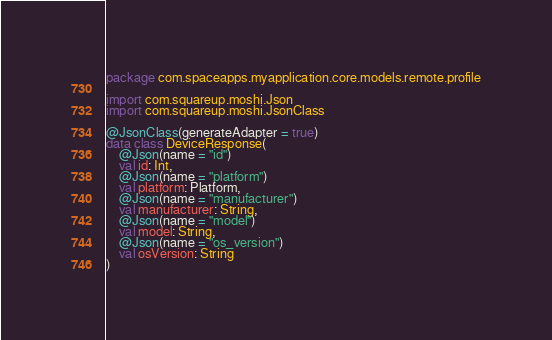Convert code to text. <code><loc_0><loc_0><loc_500><loc_500><_Kotlin_>package com.spaceapps.myapplication.core.models.remote.profile

import com.squareup.moshi.Json
import com.squareup.moshi.JsonClass

@JsonClass(generateAdapter = true)
data class DeviceResponse(
    @Json(name = "id")
    val id: Int,
    @Json(name = "platform")
    val platform: Platform,
    @Json(name = "manufacturer")
    val manufacturer: String,
    @Json(name = "model")
    val model: String,
    @Json(name = "os_version")
    val osVersion: String
)
</code> 